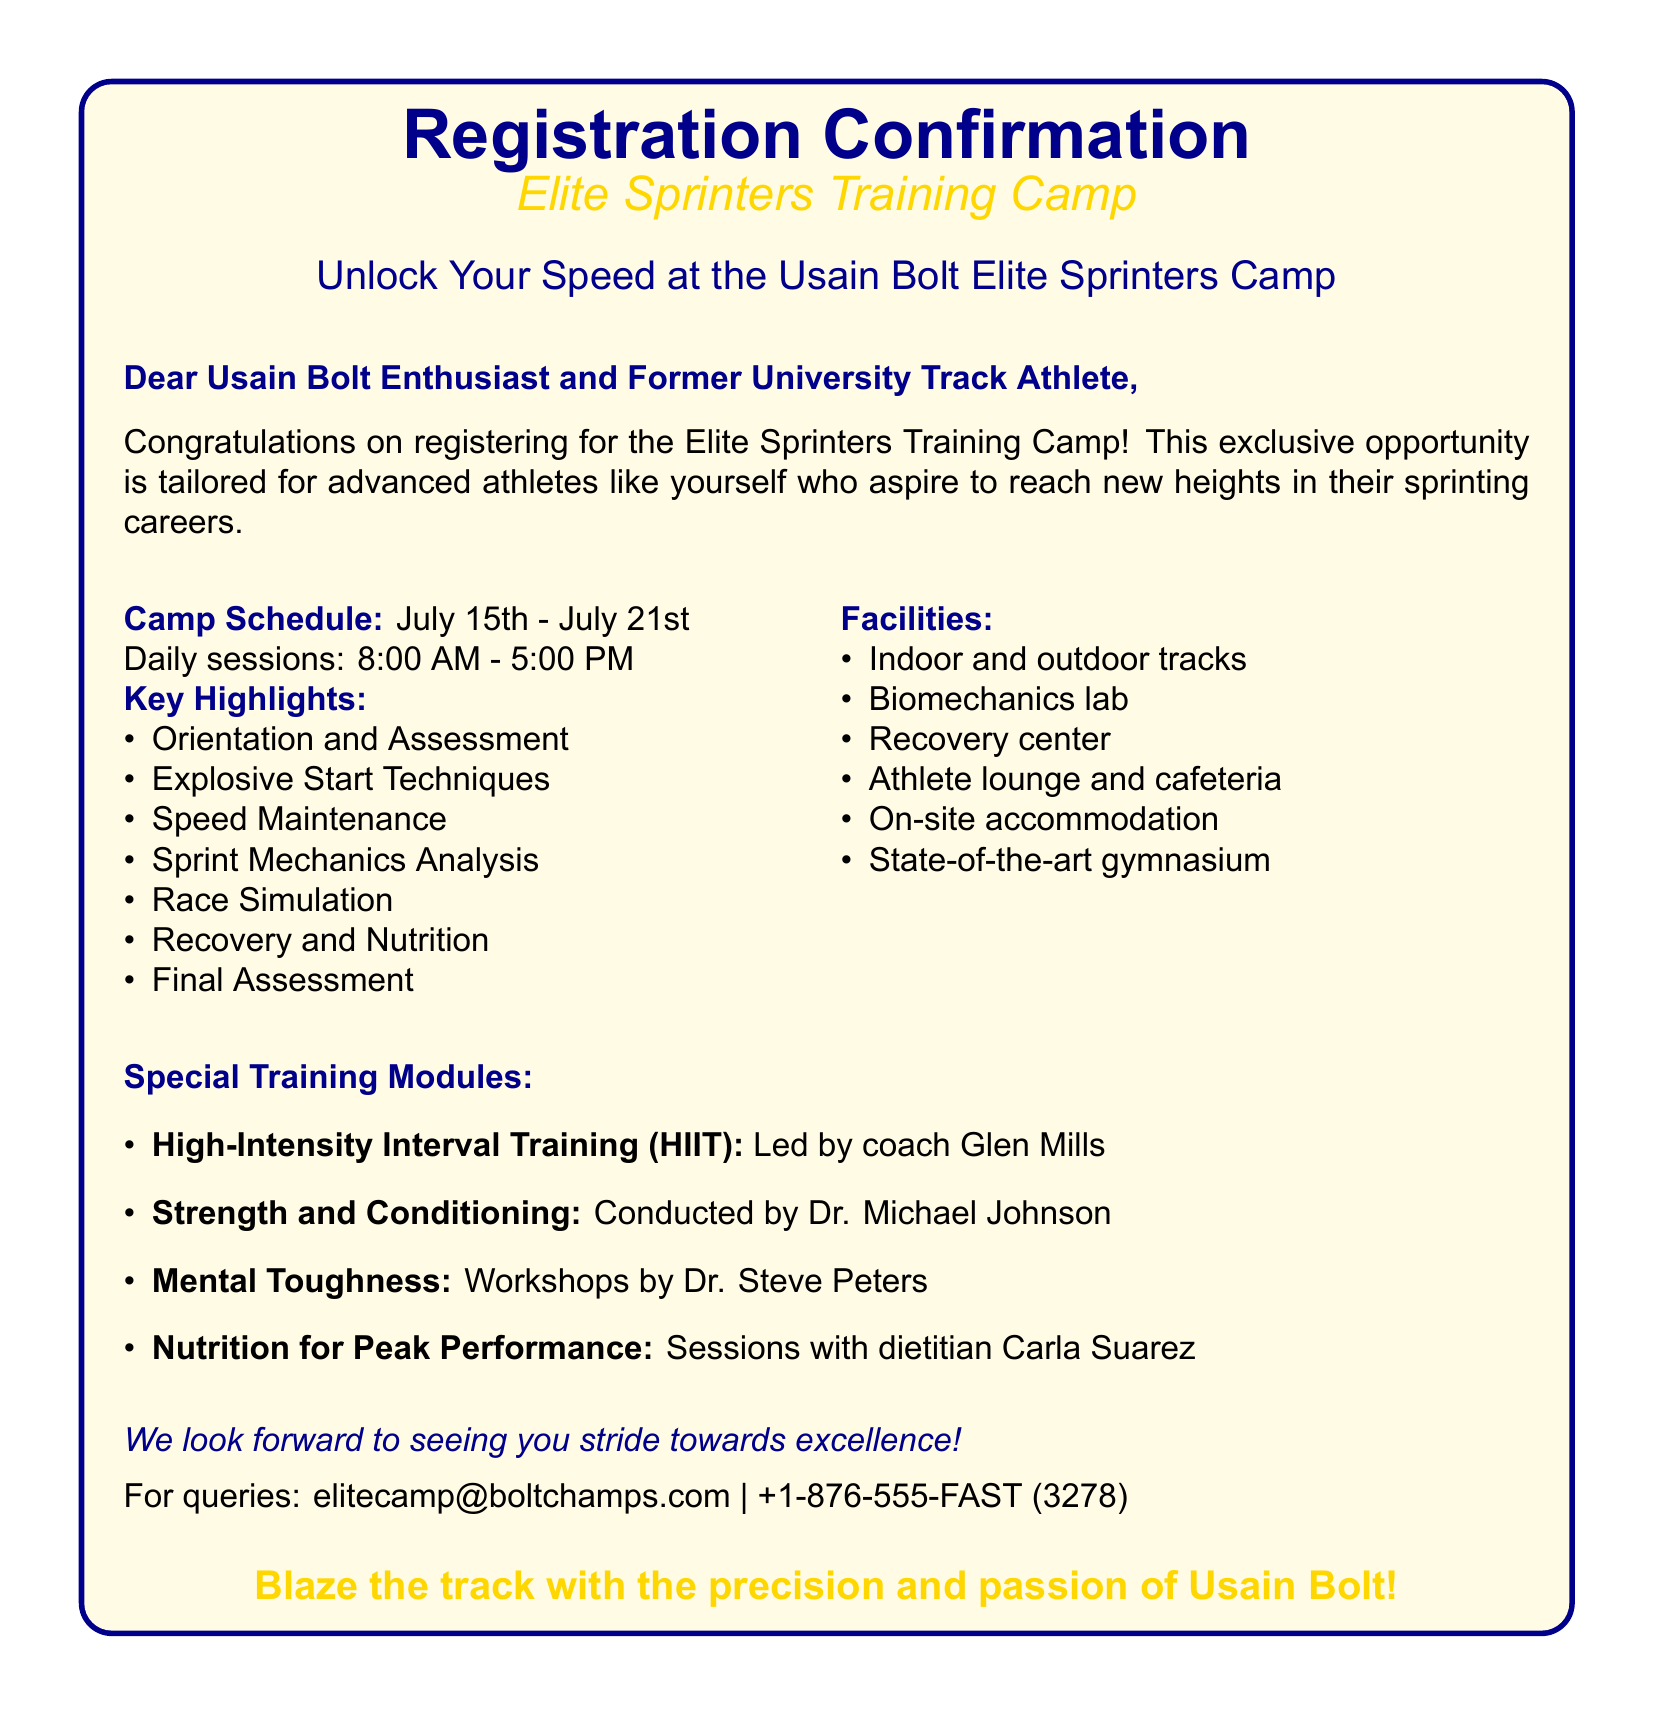What are the dates of the camp? The camp dates are explicitly mentioned in the document as July 15th - July 21st.
Answer: July 15th - July 21st What is the daily schedule for the camp? The document states that daily sessions run from 8:00 AM to 5:00 PM.
Answer: 8:00 AM - 5:00 PM Who leads the High-Intensity Interval Training module? The document specifies that coach Glen Mills leads the HIIT module.
Answer: coach Glen Mills What type of facilities are available? The document lists multiple facilities, including indoor and outdoor tracks, conveying an overall snapshot of amenities.
Answer: Indoor and outdoor tracks What special training module focuses on nutrition? The document indicates that Nutrition for Peak Performance sessions are conducted by dietitian Carla Suarez.
Answer: Nutrition for Peak Performance What is the contact email for queries? The document provides a specific email for inquiries related to the camp, which is stated directly.
Answer: elitecamp@boltchamps.com How many key highlights are there in the camp schedule? The document lists seven key highlights in the camp schedule, implicitly asking for a summary count.
Answer: Seven What is the subject of the final assessment? The document notes that a Final Assessment is included in the camp highlights, implying that it's part of the training evaluation.
Answer: Final Assessment 